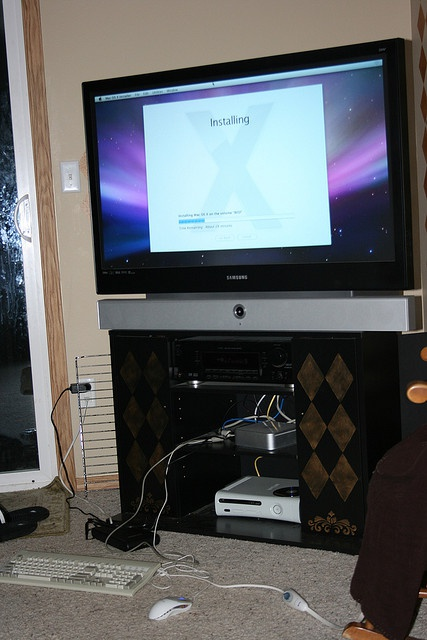Describe the objects in this image and their specific colors. I can see tv in black, lightblue, and navy tones, chair in black, gray, brown, and maroon tones, keyboard in black, gray, and darkgray tones, and mouse in black, darkgray, lightgray, and gray tones in this image. 